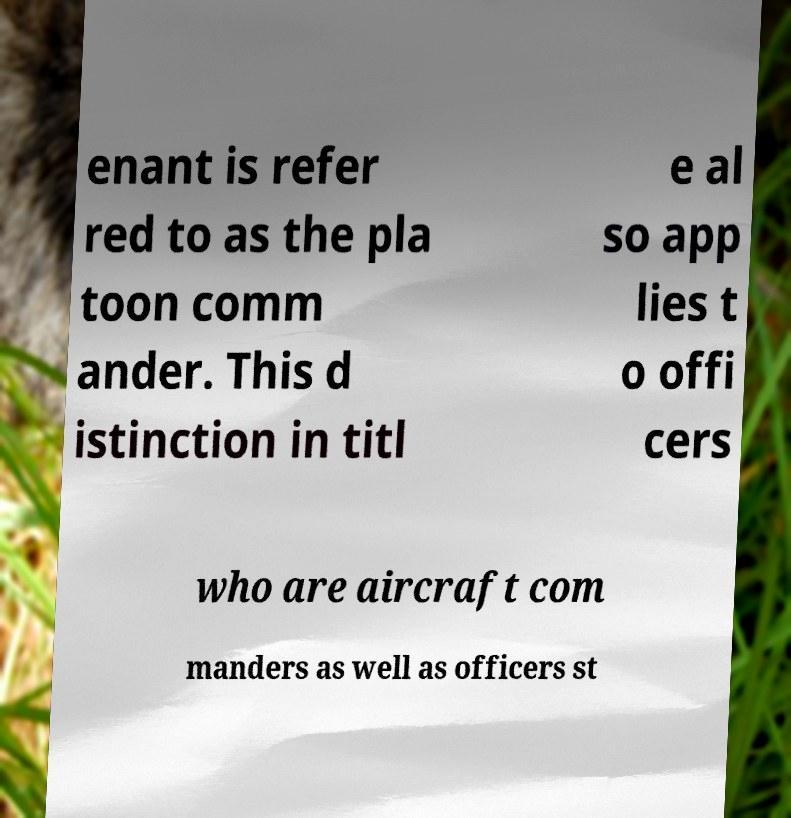Could you extract and type out the text from this image? enant is refer red to as the pla toon comm ander. This d istinction in titl e al so app lies t o offi cers who are aircraft com manders as well as officers st 